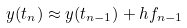Convert formula to latex. <formula><loc_0><loc_0><loc_500><loc_500>y ( t _ { n } ) \approx y ( t _ { n - 1 } ) + h f _ { n - 1 }</formula> 